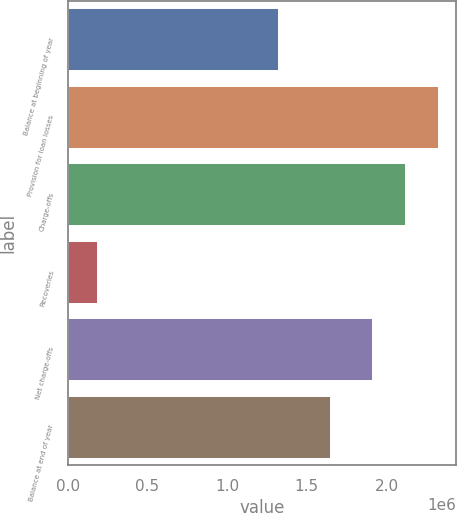Convert chart to OTSL. <chart><loc_0><loc_0><loc_500><loc_500><bar_chart><fcel>Balance at beginning of year<fcel>Provision for loan losses<fcel>Charge-offs<fcel>Recoveries<fcel>Net charge-offs<fcel>Balance at end of year<nl><fcel>1.31781e+06<fcel>2.32188e+06<fcel>2.11642e+06<fcel>185616<fcel>1.91096e+06<fcel>1.64709e+06<nl></chart> 